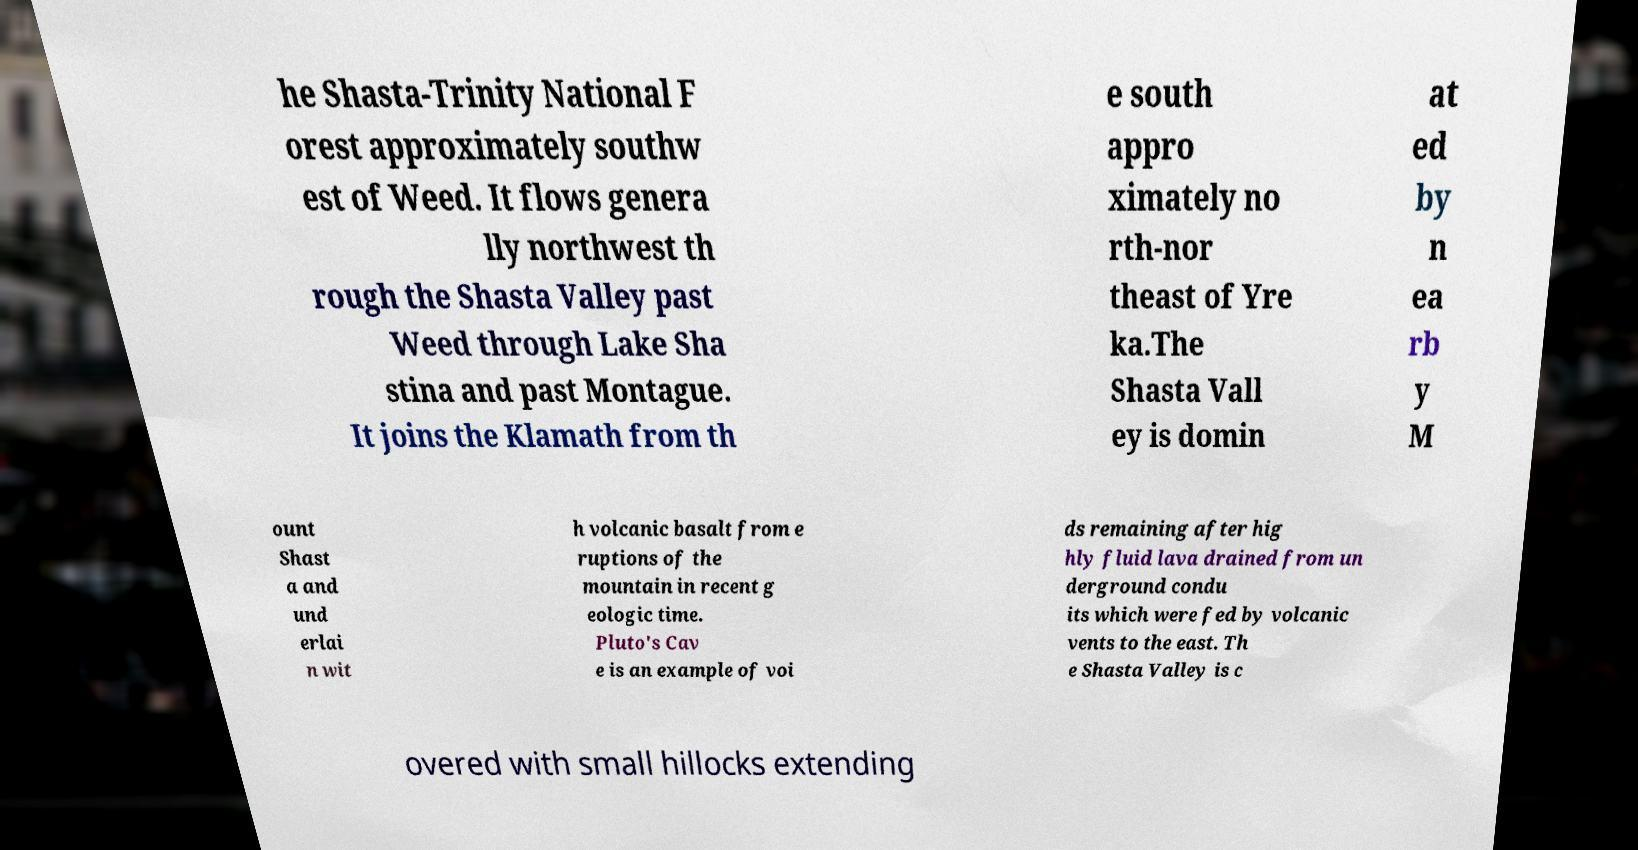I need the written content from this picture converted into text. Can you do that? he Shasta-Trinity National F orest approximately southw est of Weed. It flows genera lly northwest th rough the Shasta Valley past Weed through Lake Sha stina and past Montague. It joins the Klamath from th e south appro ximately no rth-nor theast of Yre ka.The Shasta Vall ey is domin at ed by n ea rb y M ount Shast a and und erlai n wit h volcanic basalt from e ruptions of the mountain in recent g eologic time. Pluto's Cav e is an example of voi ds remaining after hig hly fluid lava drained from un derground condu its which were fed by volcanic vents to the east. Th e Shasta Valley is c overed with small hillocks extending 